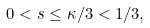<formula> <loc_0><loc_0><loc_500><loc_500>0 < s \leq \kappa / 3 < 1 / 3 ,</formula> 